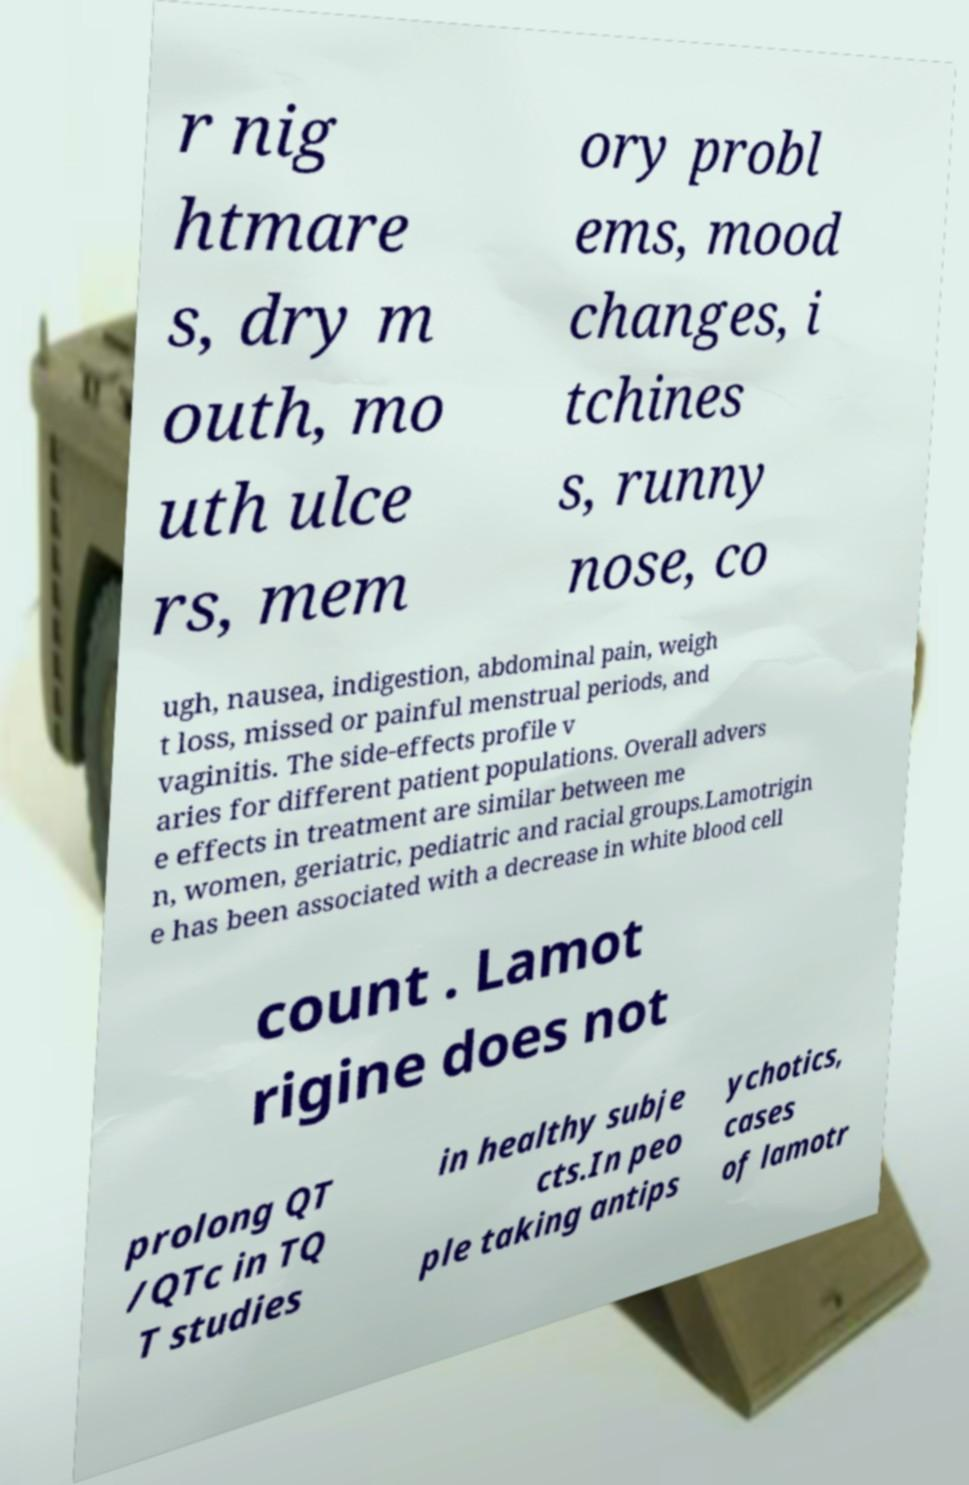I need the written content from this picture converted into text. Can you do that? r nig htmare s, dry m outh, mo uth ulce rs, mem ory probl ems, mood changes, i tchines s, runny nose, co ugh, nausea, indigestion, abdominal pain, weigh t loss, missed or painful menstrual periods, and vaginitis. The side-effects profile v aries for different patient populations. Overall advers e effects in treatment are similar between me n, women, geriatric, pediatric and racial groups.Lamotrigin e has been associated with a decrease in white blood cell count . Lamot rigine does not prolong QT /QTc in TQ T studies in healthy subje cts.In peo ple taking antips ychotics, cases of lamotr 